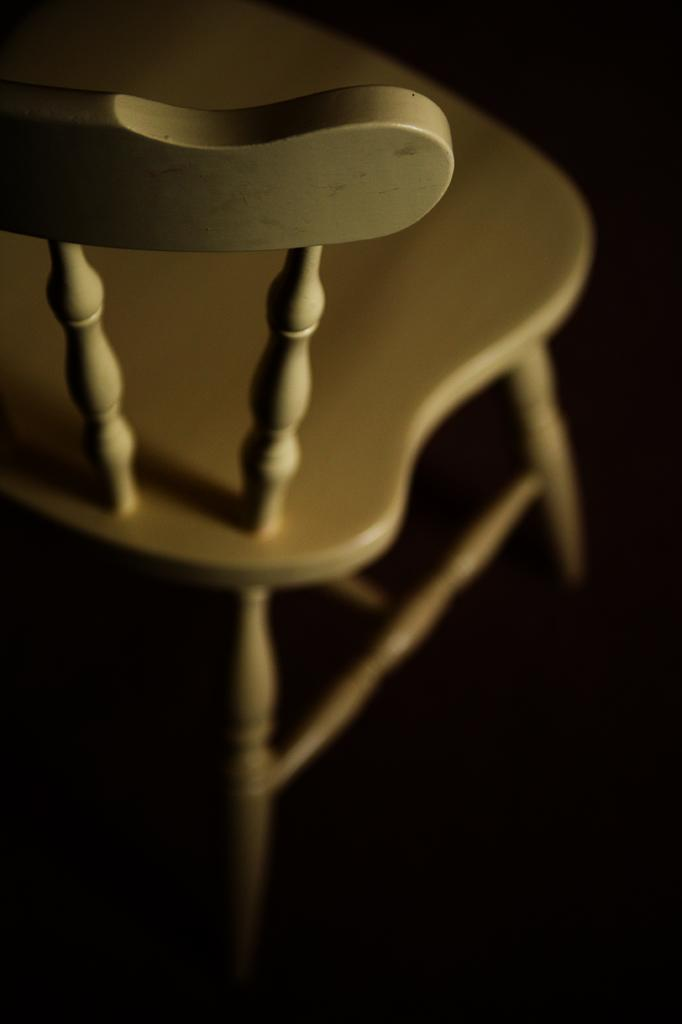What type of chair is in the image? There is a white chair in the image. What type of substance is the potato being cooked in by the dad in the image? There is no dad, potato, or cooking activity present in the image; it only features a white chair. 